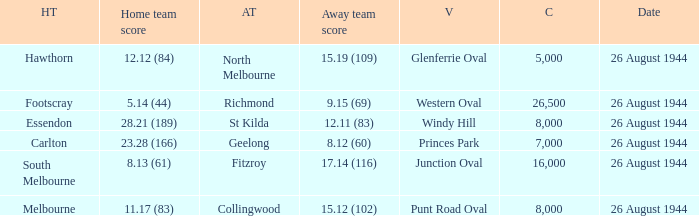What's the average crowd size when the Home team is melbourne? 8000.0. 